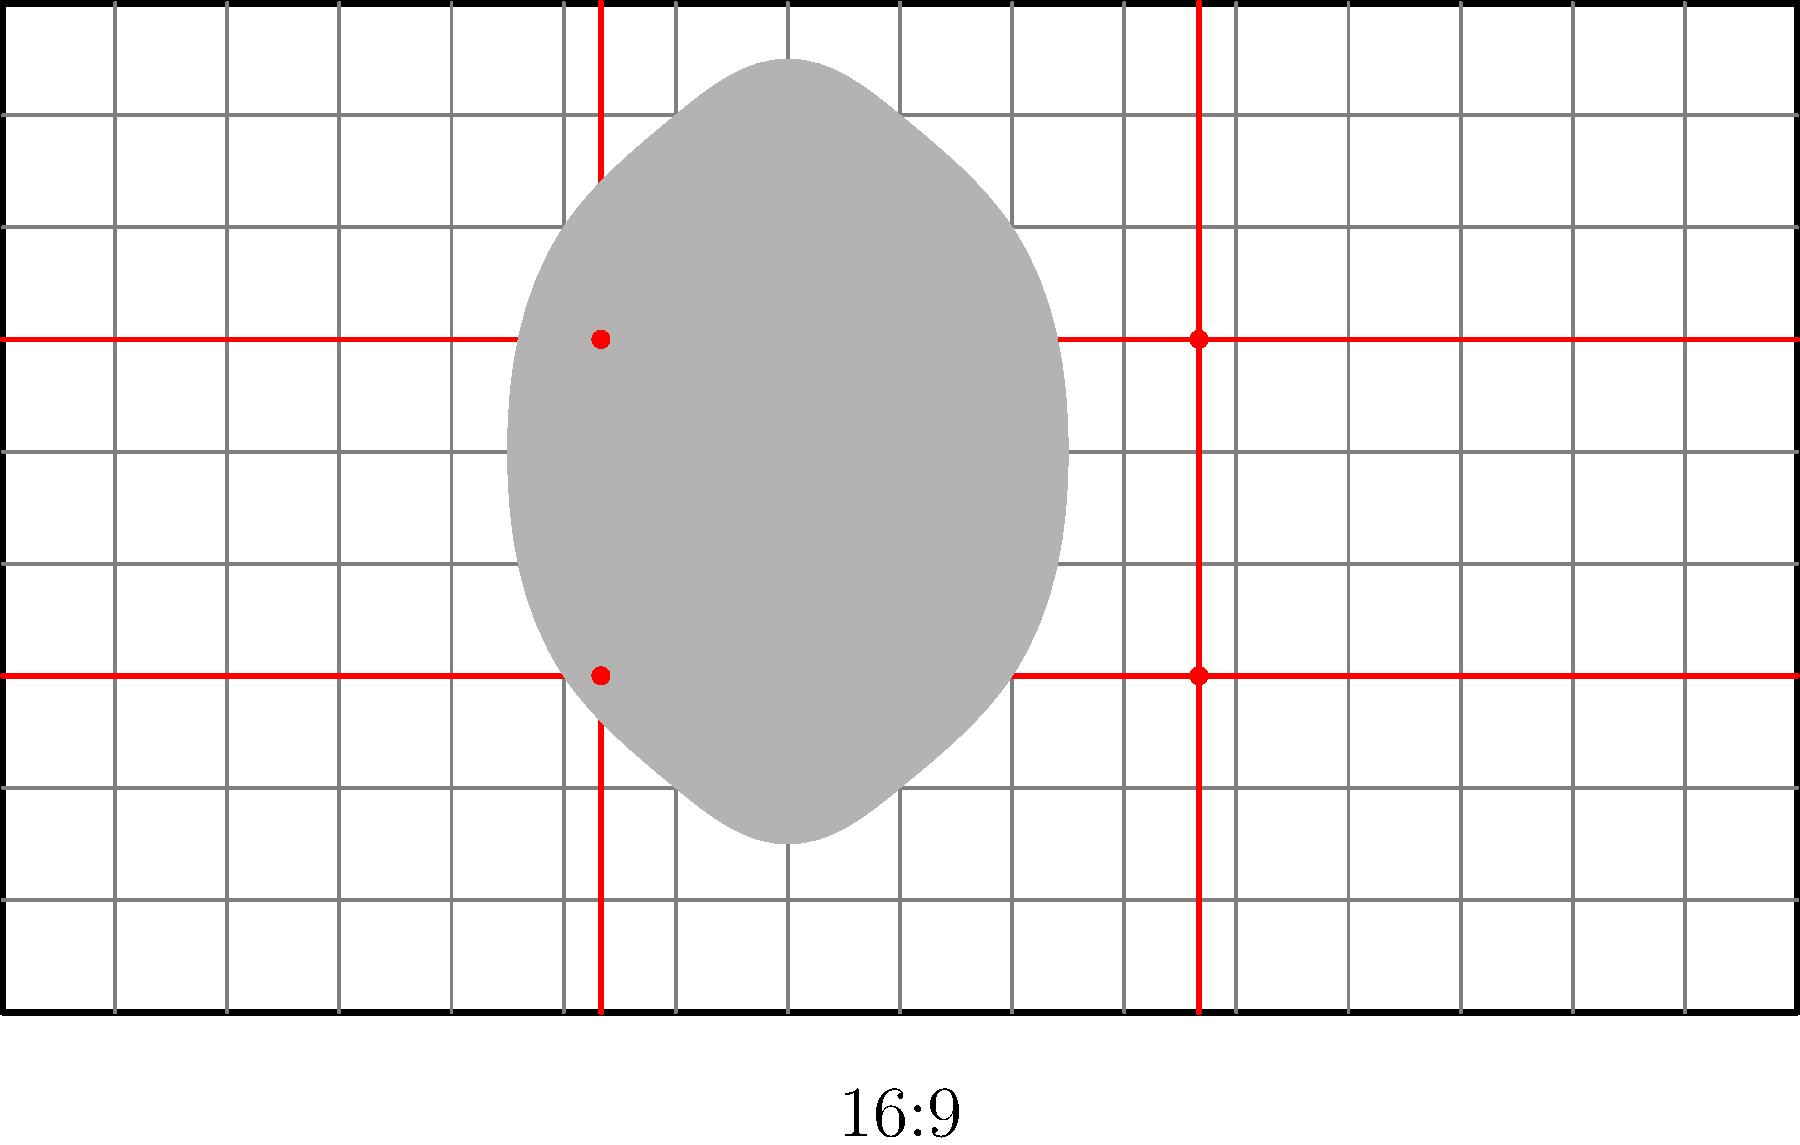In the context of anime scene composition, how does the placement of the character silhouette in this 16:9 aspect ratio frame relate to the rule of thirds, and what effect does this have on the visual impact of the scene? To analyze the composition of this anime scene:

1. Aspect Ratio: The frame has a 16:9 aspect ratio, which is standard for widescreen formats and commonly used in modern anime productions.

2. Rule of Thirds: The red lines divide the frame into a 3x3 grid, representing the rule of thirds. This guideline suggests placing key elements along these lines or at their intersections (focal points) for a more dynamic composition.

3. Character Placement: The character silhouette is positioned slightly off-center, with its core mass leaning towards the left third of the frame. This placement creates visual interest by avoiding perfect symmetry.

4. Focal Points: The character's head is near the upper-left focal point (intersection of red lines), drawing the viewer's attention to this area. This placement is often used to emphasize the character's importance or emotional state.

5. Negative Space: The positioning leaves more space on the right side of the frame, which can be used to show the environment or the direction the character is facing/moving, creating a sense of context or anticipation.

6. Balance: Despite not being centered, the composition feels balanced due to the character's placement in relation to the rule of thirds grid.

7. Visual Impact: This composition creates a dynamic and engaging scene by:
   a) Drawing attention to the character through strategic placement
   b) Creating a sense of movement or direction with the negative space
   c) Avoiding static, centered compositions that can feel less interesting

By utilizing the rule of thirds and thoughtful character placement within the 16:9 frame, the scene achieves a visually appealing and balanced composition that enhances the overall impact and storytelling of the anime.
Answer: Off-center character placement aligned with rule of thirds creates dynamic composition and visual interest. 